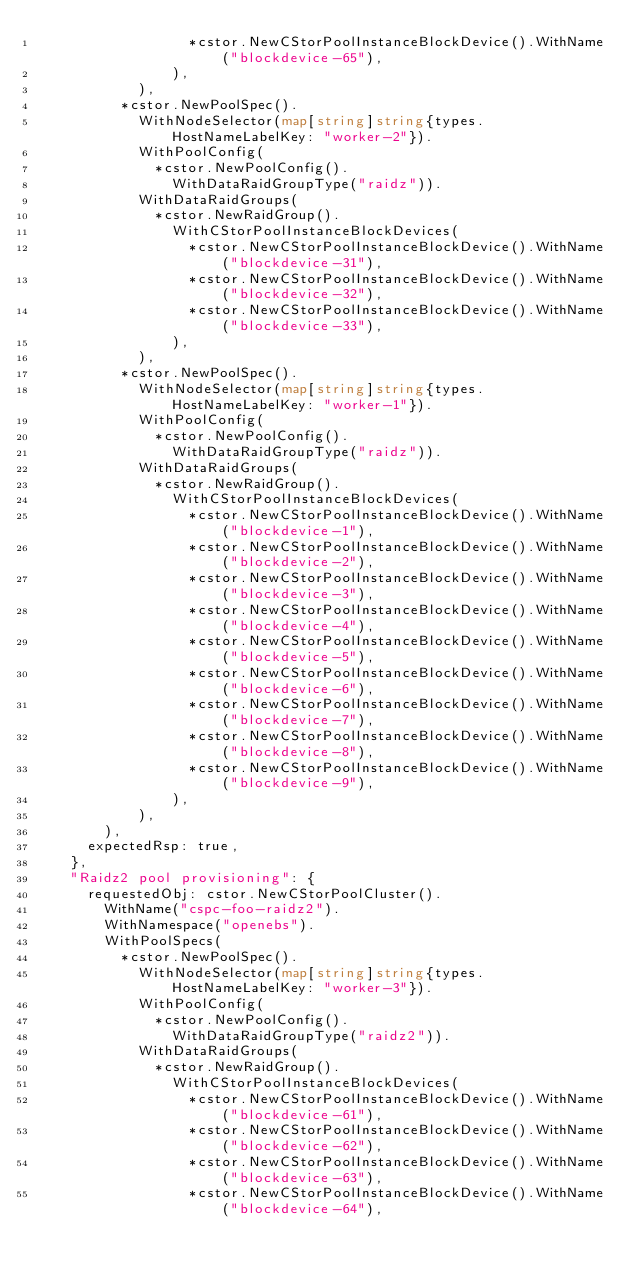Convert code to text. <code><loc_0><loc_0><loc_500><loc_500><_Go_>									*cstor.NewCStorPoolInstanceBlockDevice().WithName("blockdevice-65"),
								),
						),
					*cstor.NewPoolSpec().
						WithNodeSelector(map[string]string{types.HostNameLabelKey: "worker-2"}).
						WithPoolConfig(
							*cstor.NewPoolConfig().
								WithDataRaidGroupType("raidz")).
						WithDataRaidGroups(
							*cstor.NewRaidGroup().
								WithCStorPoolInstanceBlockDevices(
									*cstor.NewCStorPoolInstanceBlockDevice().WithName("blockdevice-31"),
									*cstor.NewCStorPoolInstanceBlockDevice().WithName("blockdevice-32"),
									*cstor.NewCStorPoolInstanceBlockDevice().WithName("blockdevice-33"),
								),
						),
					*cstor.NewPoolSpec().
						WithNodeSelector(map[string]string{types.HostNameLabelKey: "worker-1"}).
						WithPoolConfig(
							*cstor.NewPoolConfig().
								WithDataRaidGroupType("raidz")).
						WithDataRaidGroups(
							*cstor.NewRaidGroup().
								WithCStorPoolInstanceBlockDevices(
									*cstor.NewCStorPoolInstanceBlockDevice().WithName("blockdevice-1"),
									*cstor.NewCStorPoolInstanceBlockDevice().WithName("blockdevice-2"),
									*cstor.NewCStorPoolInstanceBlockDevice().WithName("blockdevice-3"),
									*cstor.NewCStorPoolInstanceBlockDevice().WithName("blockdevice-4"),
									*cstor.NewCStorPoolInstanceBlockDevice().WithName("blockdevice-5"),
									*cstor.NewCStorPoolInstanceBlockDevice().WithName("blockdevice-6"),
									*cstor.NewCStorPoolInstanceBlockDevice().WithName("blockdevice-7"),
									*cstor.NewCStorPoolInstanceBlockDevice().WithName("blockdevice-8"),
									*cstor.NewCStorPoolInstanceBlockDevice().WithName("blockdevice-9"),
								),
						),
				),
			expectedRsp: true,
		},
		"Raidz2 pool provisioning": {
			requestedObj: cstor.NewCStorPoolCluster().
				WithName("cspc-foo-raidz2").
				WithNamespace("openebs").
				WithPoolSpecs(
					*cstor.NewPoolSpec().
						WithNodeSelector(map[string]string{types.HostNameLabelKey: "worker-3"}).
						WithPoolConfig(
							*cstor.NewPoolConfig().
								WithDataRaidGroupType("raidz2")).
						WithDataRaidGroups(
							*cstor.NewRaidGroup().
								WithCStorPoolInstanceBlockDevices(
									*cstor.NewCStorPoolInstanceBlockDevice().WithName("blockdevice-61"),
									*cstor.NewCStorPoolInstanceBlockDevice().WithName("blockdevice-62"),
									*cstor.NewCStorPoolInstanceBlockDevice().WithName("blockdevice-63"),
									*cstor.NewCStorPoolInstanceBlockDevice().WithName("blockdevice-64"),</code> 